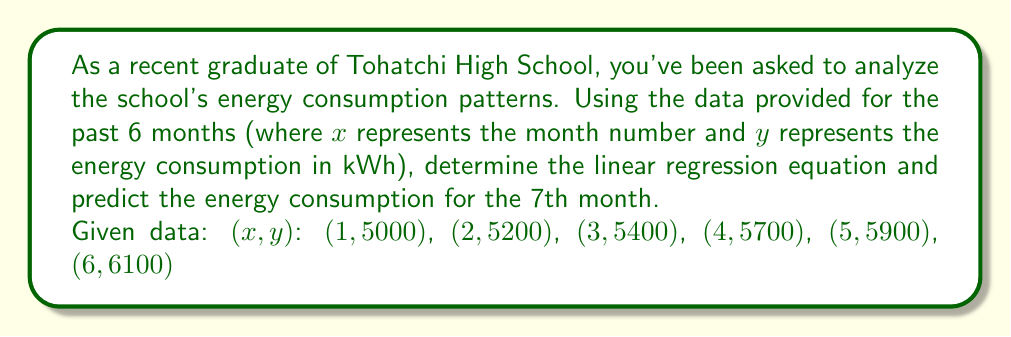Give your solution to this math problem. To find the linear regression equation and predict the energy consumption, we'll follow these steps:

1. Calculate the means of $x$ and $y$:
   $\bar{x} = \frac{1+2+3+4+5+6}{6} = 3.5$
   $\bar{y} = \frac{5000+5200+5400+5700+5900+6100}{6} = 5550$

2. Calculate $\sum{(x-\bar{x})(y-\bar{y})}$ and $\sum{(x-\bar{x})^2}$:
   $\sum{(x-\bar{x})(y-\bar{y})} = 2275$
   $\sum{(x-\bar{x})^2} = 17.5$

3. Calculate the slope $m$:
   $m = \frac{\sum{(x-\bar{x})(y-\bar{y})}}{\sum{(x-\bar{x})^2}} = \frac{2275}{17.5} = 130$

4. Calculate the y-intercept $b$:
   $b = \bar{y} - m\bar{x} = 5550 - 130(3.5) = 5095$

5. Form the linear regression equation:
   $y = 130x + 5095$

6. Predict the energy consumption for the 7th month:
   $y = 130(7) + 5095 = 6005$

Therefore, the linear regression equation is $y = 130x + 5095$, and the predicted energy consumption for the 7th month is 6005 kWh.
Answer: $y = 130x + 5095$; 6005 kWh 